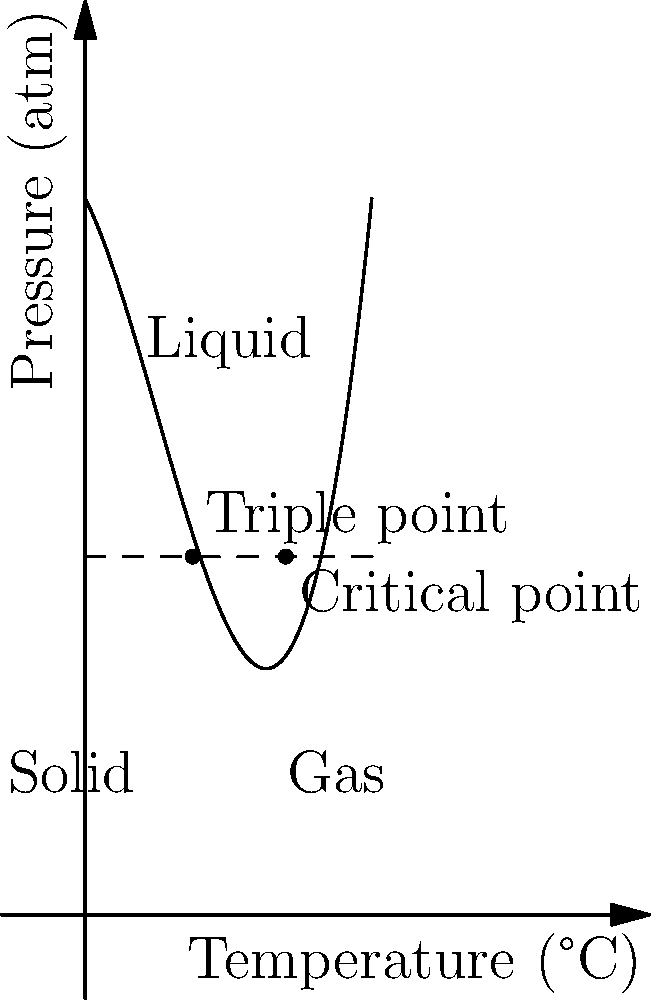As a pharmacist evaluating the stability of a new pharmaceutical compound, you are presented with its phase diagram. At what temperature does the compound exist in all three phases simultaneously, and what is the significance of this point in pharmaceutical storage and handling? To answer this question, we need to analyze the phase diagram:

1. Identify the triple point: This is where all three phases (solid, liquid, and gas) coexist in equilibrium.

2. Locate the triple point on the diagram: It's at the intersection of all three phase boundaries, labeled "Triple point" on the graph.

3. Determine the temperature: The x-axis represents temperature. The triple point appears to be at approximately 1.5°C.

4. Understand the significance:
   a) At this specific temperature and pressure, the compound can exist in all three phases simultaneously.
   b) Any slight change in temperature or pressure can cause a phase transition.
   c) This point is crucial for pharmaceutical storage and handling because:
      - It represents the lowest pressure at which the liquid phase can exist.
      - It's a critical point for freeze-drying (lyophilization) processes.
      - It helps determine suitable storage conditions to maintain the compound's stability.
      - It informs packaging decisions to prevent unwanted phase transitions during transport and storage.

5. In practice, pharmacists use this information to:
   - Design appropriate storage conditions.
   - Develop stable formulations.
   - Optimize lyophilization processes for injectable or other sensitive medications.
   - Ensure product quality throughout the supply chain.
Answer: 1.5°C; critical for stability, storage, and lyophilization processes. 